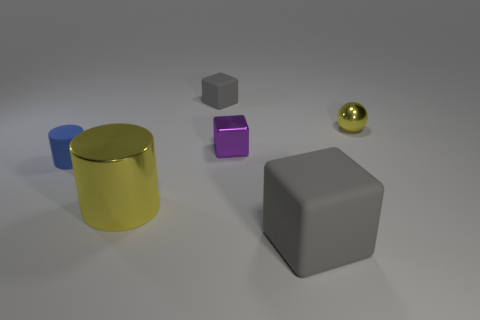How many big cylinders are left of the rubber block in front of the shiny object behind the small purple cube?
Make the answer very short. 1. Do the tiny matte block and the big object on the right side of the small purple metal cube have the same color?
Your response must be concise. Yes. There is a cylinder that is the same material as the tiny purple thing; what is its size?
Make the answer very short. Large. Is the number of small purple metal blocks that are to the right of the small ball greater than the number of tiny red rubber cubes?
Your answer should be very brief. No. The small purple thing left of the gray rubber block on the right side of the matte object behind the blue cylinder is made of what material?
Offer a terse response. Metal. Is the small purple cube made of the same material as the gray cube left of the big rubber object?
Provide a succinct answer. No. There is a small purple object that is the same shape as the big gray rubber object; what material is it?
Give a very brief answer. Metal. Is the number of cubes in front of the small gray rubber object greater than the number of small gray rubber objects right of the large gray object?
Ensure brevity in your answer.  Yes. There is a large gray thing that is made of the same material as the blue object; what is its shape?
Your answer should be compact. Cube. What number of other things are the same shape as the big rubber object?
Offer a very short reply. 2. 